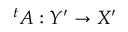Convert formula to latex. <formula><loc_0><loc_0><loc_500><loc_500>{ } ^ { t } A \colon Y ^ { \prime } \to X ^ { \prime }</formula> 